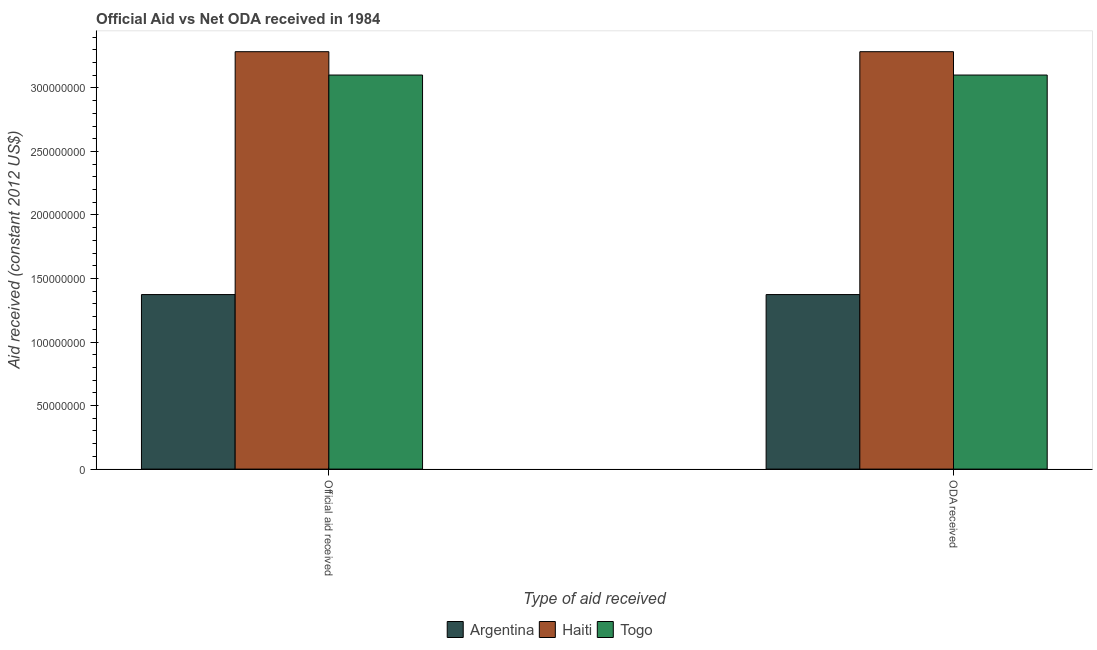How many different coloured bars are there?
Provide a short and direct response. 3. How many groups of bars are there?
Make the answer very short. 2. Are the number of bars per tick equal to the number of legend labels?
Keep it short and to the point. Yes. How many bars are there on the 1st tick from the right?
Your answer should be very brief. 3. What is the label of the 2nd group of bars from the left?
Keep it short and to the point. ODA received. What is the official aid received in Togo?
Ensure brevity in your answer.  3.10e+08. Across all countries, what is the maximum oda received?
Offer a terse response. 3.29e+08. Across all countries, what is the minimum official aid received?
Keep it short and to the point. 1.37e+08. In which country was the oda received maximum?
Offer a terse response. Haiti. What is the total oda received in the graph?
Your answer should be compact. 7.76e+08. What is the difference between the official aid received in Haiti and that in Argentina?
Provide a succinct answer. 1.91e+08. What is the difference between the oda received in Argentina and the official aid received in Haiti?
Make the answer very short. -1.91e+08. What is the average oda received per country?
Offer a very short reply. 2.59e+08. In how many countries, is the oda received greater than 190000000 US$?
Provide a succinct answer. 2. What is the ratio of the oda received in Togo to that in Haiti?
Your answer should be compact. 0.94. Is the oda received in Haiti less than that in Argentina?
Provide a succinct answer. No. In how many countries, is the official aid received greater than the average official aid received taken over all countries?
Make the answer very short. 2. What does the 3rd bar from the left in Official aid received represents?
Keep it short and to the point. Togo. What does the 3rd bar from the right in Official aid received represents?
Your answer should be compact. Argentina. How many bars are there?
Provide a succinct answer. 6. How many countries are there in the graph?
Make the answer very short. 3. Are the values on the major ticks of Y-axis written in scientific E-notation?
Ensure brevity in your answer.  No. Does the graph contain grids?
Offer a terse response. No. What is the title of the graph?
Offer a terse response. Official Aid vs Net ODA received in 1984 . What is the label or title of the X-axis?
Keep it short and to the point. Type of aid received. What is the label or title of the Y-axis?
Your answer should be compact. Aid received (constant 2012 US$). What is the Aid received (constant 2012 US$) in Argentina in Official aid received?
Provide a short and direct response. 1.37e+08. What is the Aid received (constant 2012 US$) of Haiti in Official aid received?
Your response must be concise. 3.29e+08. What is the Aid received (constant 2012 US$) in Togo in Official aid received?
Offer a very short reply. 3.10e+08. What is the Aid received (constant 2012 US$) in Argentina in ODA received?
Provide a succinct answer. 1.37e+08. What is the Aid received (constant 2012 US$) of Haiti in ODA received?
Your response must be concise. 3.29e+08. What is the Aid received (constant 2012 US$) in Togo in ODA received?
Ensure brevity in your answer.  3.10e+08. Across all Type of aid received, what is the maximum Aid received (constant 2012 US$) of Argentina?
Ensure brevity in your answer.  1.37e+08. Across all Type of aid received, what is the maximum Aid received (constant 2012 US$) in Haiti?
Your response must be concise. 3.29e+08. Across all Type of aid received, what is the maximum Aid received (constant 2012 US$) of Togo?
Offer a terse response. 3.10e+08. Across all Type of aid received, what is the minimum Aid received (constant 2012 US$) of Argentina?
Offer a terse response. 1.37e+08. Across all Type of aid received, what is the minimum Aid received (constant 2012 US$) in Haiti?
Make the answer very short. 3.29e+08. Across all Type of aid received, what is the minimum Aid received (constant 2012 US$) in Togo?
Your answer should be compact. 3.10e+08. What is the total Aid received (constant 2012 US$) of Argentina in the graph?
Give a very brief answer. 2.75e+08. What is the total Aid received (constant 2012 US$) in Haiti in the graph?
Keep it short and to the point. 6.57e+08. What is the total Aid received (constant 2012 US$) of Togo in the graph?
Provide a short and direct response. 6.20e+08. What is the difference between the Aid received (constant 2012 US$) of Argentina in Official aid received and that in ODA received?
Your answer should be very brief. 0. What is the difference between the Aid received (constant 2012 US$) in Argentina in Official aid received and the Aid received (constant 2012 US$) in Haiti in ODA received?
Offer a very short reply. -1.91e+08. What is the difference between the Aid received (constant 2012 US$) of Argentina in Official aid received and the Aid received (constant 2012 US$) of Togo in ODA received?
Offer a terse response. -1.73e+08. What is the difference between the Aid received (constant 2012 US$) in Haiti in Official aid received and the Aid received (constant 2012 US$) in Togo in ODA received?
Give a very brief answer. 1.84e+07. What is the average Aid received (constant 2012 US$) of Argentina per Type of aid received?
Keep it short and to the point. 1.37e+08. What is the average Aid received (constant 2012 US$) in Haiti per Type of aid received?
Make the answer very short. 3.29e+08. What is the average Aid received (constant 2012 US$) of Togo per Type of aid received?
Your answer should be very brief. 3.10e+08. What is the difference between the Aid received (constant 2012 US$) of Argentina and Aid received (constant 2012 US$) of Haiti in Official aid received?
Your answer should be very brief. -1.91e+08. What is the difference between the Aid received (constant 2012 US$) in Argentina and Aid received (constant 2012 US$) in Togo in Official aid received?
Offer a very short reply. -1.73e+08. What is the difference between the Aid received (constant 2012 US$) of Haiti and Aid received (constant 2012 US$) of Togo in Official aid received?
Provide a succinct answer. 1.84e+07. What is the difference between the Aid received (constant 2012 US$) in Argentina and Aid received (constant 2012 US$) in Haiti in ODA received?
Ensure brevity in your answer.  -1.91e+08. What is the difference between the Aid received (constant 2012 US$) of Argentina and Aid received (constant 2012 US$) of Togo in ODA received?
Ensure brevity in your answer.  -1.73e+08. What is the difference between the Aid received (constant 2012 US$) of Haiti and Aid received (constant 2012 US$) of Togo in ODA received?
Provide a short and direct response. 1.84e+07. What is the ratio of the Aid received (constant 2012 US$) of Argentina in Official aid received to that in ODA received?
Provide a short and direct response. 1. What is the difference between the highest and the second highest Aid received (constant 2012 US$) in Togo?
Your answer should be very brief. 0. What is the difference between the highest and the lowest Aid received (constant 2012 US$) in Haiti?
Your answer should be very brief. 0. What is the difference between the highest and the lowest Aid received (constant 2012 US$) of Togo?
Ensure brevity in your answer.  0. 